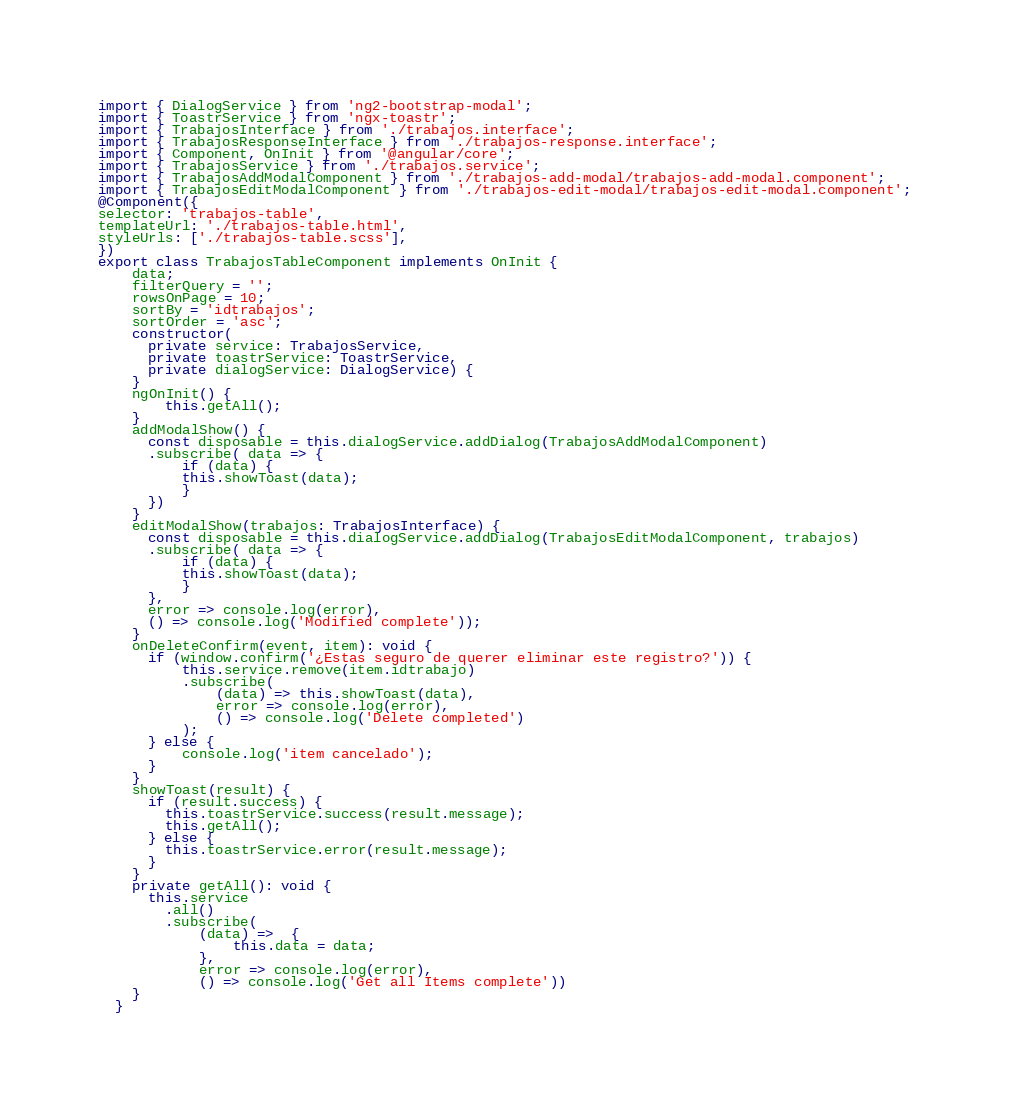<code> <loc_0><loc_0><loc_500><loc_500><_TypeScript_>import { DialogService } from 'ng2-bootstrap-modal';
import { ToastrService } from 'ngx-toastr';
import { TrabajosInterface } from './trabajos.interface';
import { TrabajosResponseInterface } from './trabajos-response.interface';
import { Component, OnInit } from '@angular/core';
import { TrabajosService } from './trabajos.service';
import { TrabajosAddModalComponent } from './trabajos-add-modal/trabajos-add-modal.component';
import { TrabajosEditModalComponent } from './trabajos-edit-modal/trabajos-edit-modal.component';
@Component({
selector: 'trabajos-table',
templateUrl: './trabajos-table.html',
styleUrls: ['./trabajos-table.scss'],
})
export class TrabajosTableComponent implements OnInit {
    data;
    filterQuery = '';
    rowsOnPage = 10;
    sortBy = 'idtrabajos';
    sortOrder = 'asc';
    constructor(
      private service: TrabajosService, 
      private toastrService: ToastrService, 
      private dialogService: DialogService) {
    }
    ngOnInit() {
        this.getAll();
    }
    addModalShow() {
      const disposable = this.dialogService.addDialog(TrabajosAddModalComponent)
      .subscribe( data => {
          if (data) {
          this.showToast(data);
          }
      })
    }
    editModalShow(trabajos: TrabajosInterface) {
      const disposable = this.dialogService.addDialog(TrabajosEditModalComponent, trabajos)
      .subscribe( data => {
          if (data) {
          this.showToast(data);
          }
      },
      error => console.log(error),
      () => console.log('Modified complete'));
    }
    onDeleteConfirm(event, item): void {
      if (window.confirm('¿Estas seguro de querer eliminar este registro?')) {
          this.service.remove(item.idtrabajo)
          .subscribe(
              (data) => this.showToast(data),
              error => console.log(error),
              () => console.log('Delete completed')
          );
      } else {
          console.log('item cancelado');
      }
    }
    showToast(result) {
      if (result.success) {
        this.toastrService.success(result.message);
        this.getAll();
      } else {
        this.toastrService.error(result.message);
      }
    }
    private getAll(): void {
      this.service
        .all()
        .subscribe(
            (data) =>  {
                this.data = data;
            },
            error => console.log(error),
            () => console.log('Get all Items complete'))
    } 
  }
</code> 